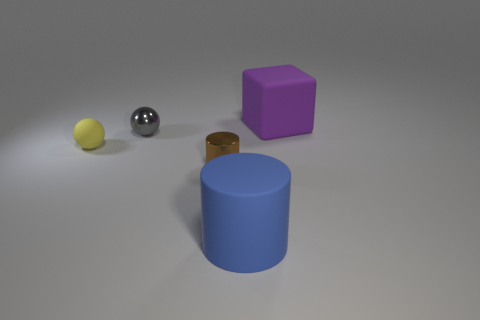There is a small thing that is right of the small matte ball and in front of the gray metal ball; what material is it made of?
Offer a very short reply. Metal. What size is the brown cylinder?
Ensure brevity in your answer.  Small. What number of big blue objects are left of the cylinder left of the big rubber thing in front of the brown shiny object?
Offer a terse response. 0. There is a big matte thing right of the big thing that is in front of the large cube; what is its shape?
Offer a very short reply. Cube. The blue object that is the same shape as the brown shiny thing is what size?
Make the answer very short. Large. Are there any other things that have the same size as the block?
Your response must be concise. Yes. What is the color of the big object that is to the left of the big purple block?
Your answer should be very brief. Blue. What material is the large thing that is to the left of the big matte thing that is on the right side of the large object that is in front of the block?
Your answer should be very brief. Rubber. What is the size of the metallic object behind the rubber ball that is in front of the gray ball?
Your answer should be compact. Small. There is another small thing that is the same shape as the blue rubber object; what is its color?
Provide a succinct answer. Brown. 